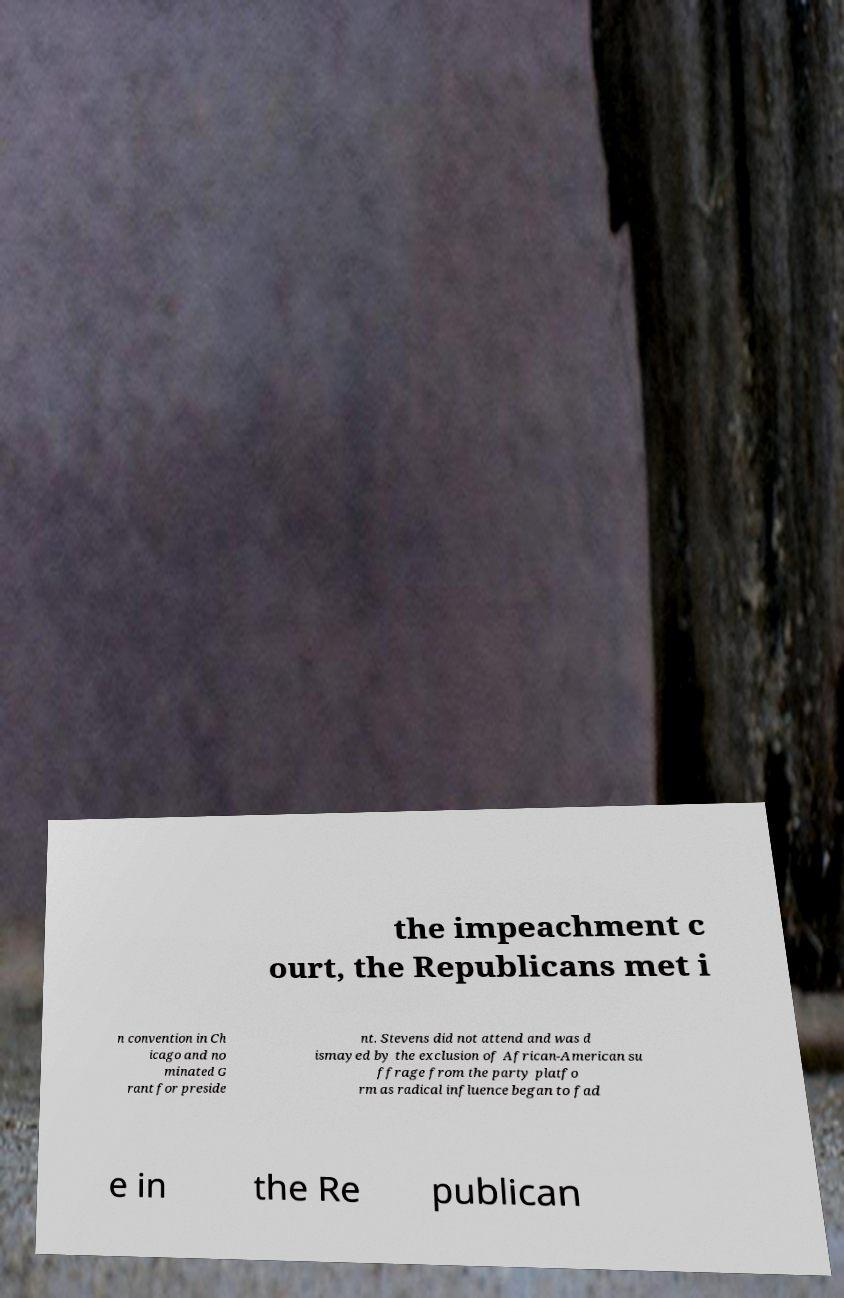Could you extract and type out the text from this image? the impeachment c ourt, the Republicans met i n convention in Ch icago and no minated G rant for preside nt. Stevens did not attend and was d ismayed by the exclusion of African-American su ffrage from the party platfo rm as radical influence began to fad e in the Re publican 